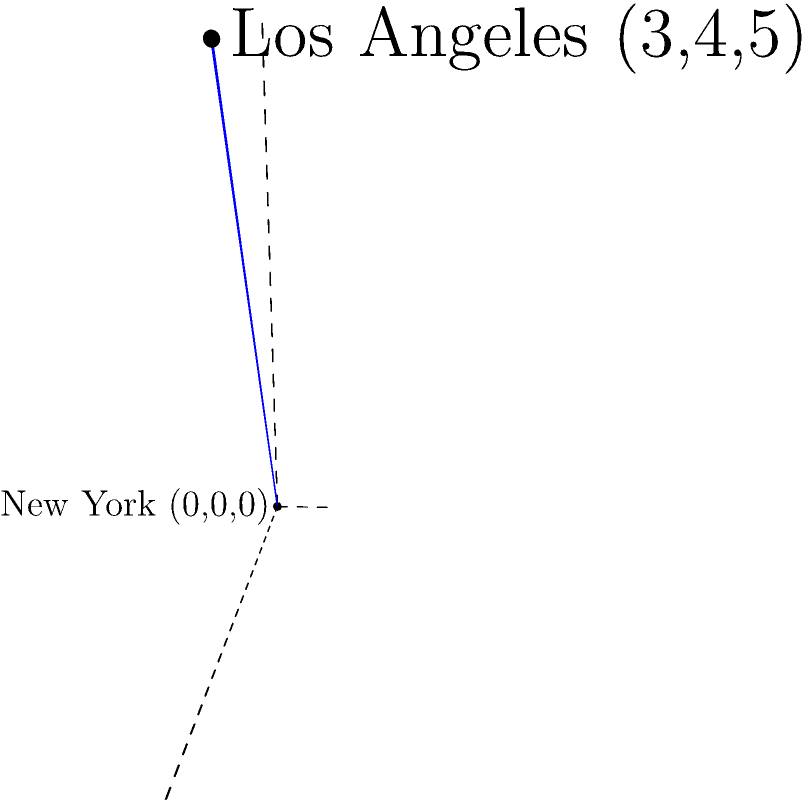As a TikTok star, you're planning collaborations in different cities. Your latest viral video was filmed in New York (coordinates: 0, 0, 0), and you're considering collaborating with another creator in Los Angeles (coordinates: 3, 4, 5). To estimate travel costs, you need to calculate the straight-line distance between these two locations. Using the distance formula in 3D space, what is the distance between New York and Los Angeles in coordinate units? To solve this problem, we'll use the distance formula in 3D space:

$$d = \sqrt{(x_2-x_1)^2 + (y_2-y_1)^2 + (z_2-z_1)^2}$$

Where:
$(x_1, y_1, z_1)$ is the coordinate of New York (0, 0, 0)
$(x_2, y_2, z_2)$ is the coordinate of Los Angeles (3, 4, 5)

Let's plug in the values:

$$d = \sqrt{(3-0)^2 + (4-0)^2 + (5-0)^2}$$

Simplify:
$$d = \sqrt{3^2 + 4^2 + 5^2}$$

Calculate the squares:
$$d = \sqrt{9 + 16 + 25}$$

Add the values under the square root:
$$d = \sqrt{50}$$

Simplify the square root:
$$d = 5\sqrt{2}$$

This is the exact answer. If we want a decimal approximation:
$$d \approx 7.07$$

So, the distance between New York and Los Angeles in these coordinate units is $5\sqrt{2}$ or approximately 7.07 units.
Answer: $5\sqrt{2}$ units 